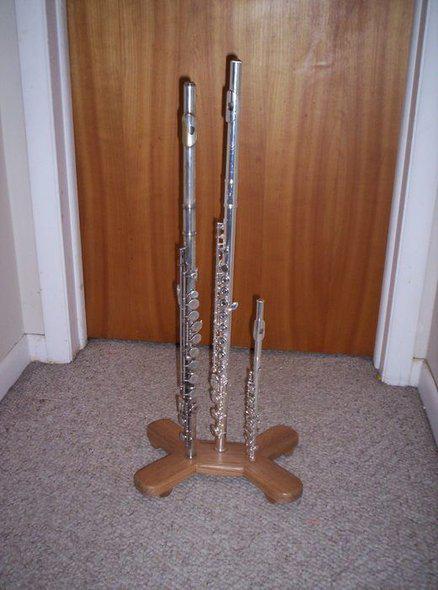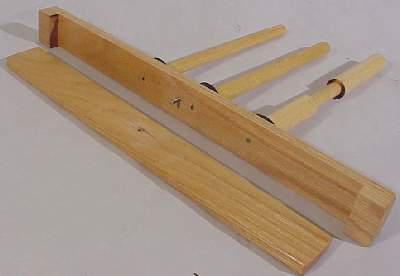The first image is the image on the left, the second image is the image on the right. Analyze the images presented: Is the assertion "In the image to the right, three parts of a flute are held horizontally." valid? Answer yes or no. No. 